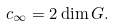<formula> <loc_0><loc_0><loc_500><loc_500>c _ { \infty } = 2 \dim G .</formula> 